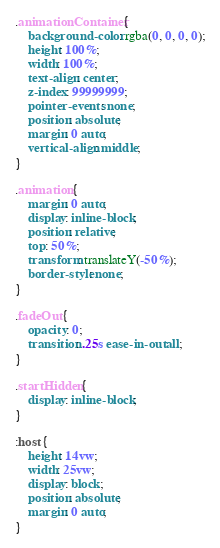Convert code to text. <code><loc_0><loc_0><loc_500><loc_500><_CSS_>.animationContainer {
    background-color: rgba(0, 0, 0, 0);
    height: 100%;
    width: 100%;
    text-align: center;
    z-index: 99999999;
    pointer-events: none;
    position: absolute;
    margin: 0 auto;
    vertical-align: middle;
}

.animation {
    margin: 0 auto;
    display: inline-block;
    position: relative;
    top: 50%;
    transform: translateY(-50%);
    border-style: none;
}

.fadeOut {
    opacity: 0;
    transition: .25s ease-in-out all;
}

.startHidden {
    display: inline-block;
}

:host {
    height: 14vw;
    width: 25vw;
    display: block;
    position: absolute;
    margin: 0 auto;
}
</code> 